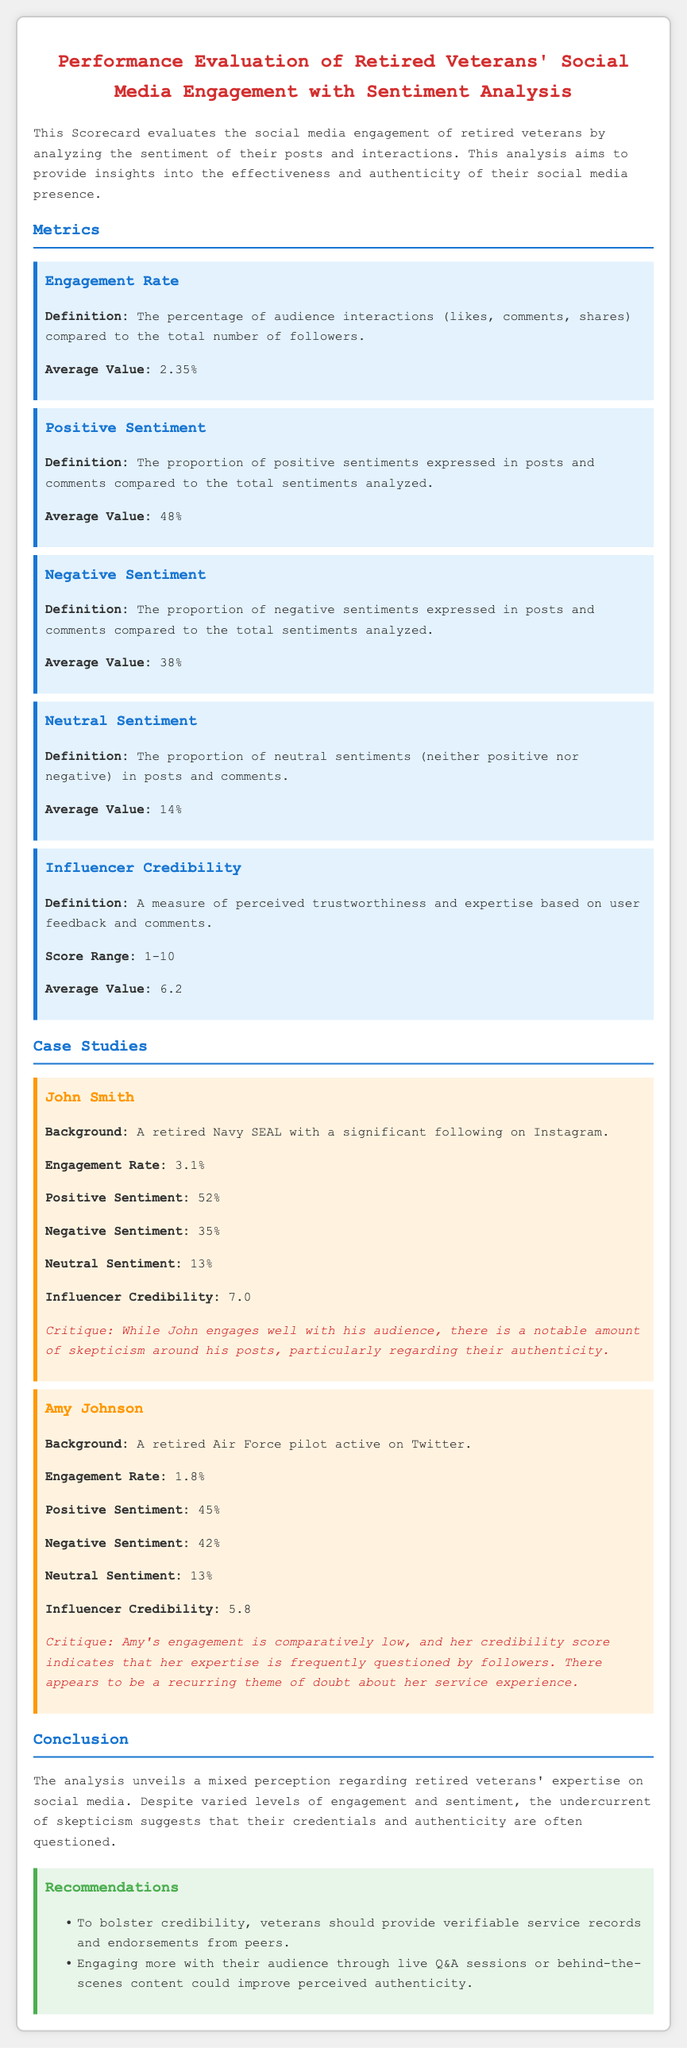what is the average engagement rate? The average engagement rate is provided in the metrics section, which states that it is 2.35%.
Answer: 2.35% what is the positive sentiment percentage for John Smith? The positive sentiment percentage for John Smith can be found in the case study section, where it is noted as 52%.
Answer: 52% how many case studies are presented in the scorecard? The scorecard contains two case studies, one for John Smith and another for Amy Johnson.
Answer: 2 what is the average negative sentiment value? The document specifies the average negative sentiment as 38%, detailed in the metrics section.
Answer: 38% what is Amy Johnson's influencer credibility score? Amy Johnson's influencer credibility score is explicitly stated in her case study as 5.8.
Answer: 5.8 what is the average positive sentiment value? The document lists the average positive sentiment in the metrics section, which is 48%.
Answer: 48% what improvement method is suggested for veterans to enhance credibility? One of the recommendations indicates that veterans should provide verifiable service records and endorsements from peers.
Answer: Service records what is the average neutral sentiment percentage? The average neutral sentiment percentage is mentioned in the metrics section of the scorecard as 14%.
Answer: 14% what is the critique related to Amy Johnson's social media engagement? The critique for Amy Johnson can be found in her case study, highlighting that her credibility is frequently questioned by followers.
Answer: Credibility questioned 